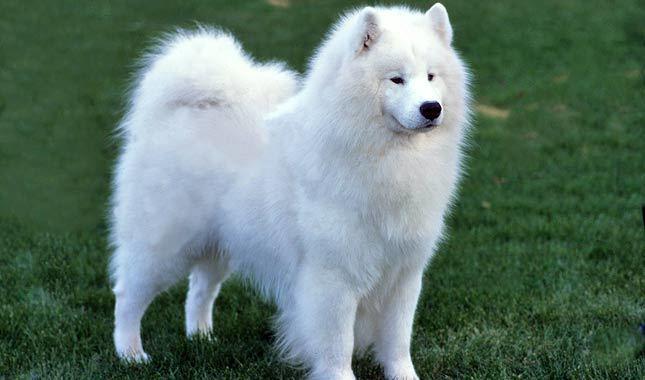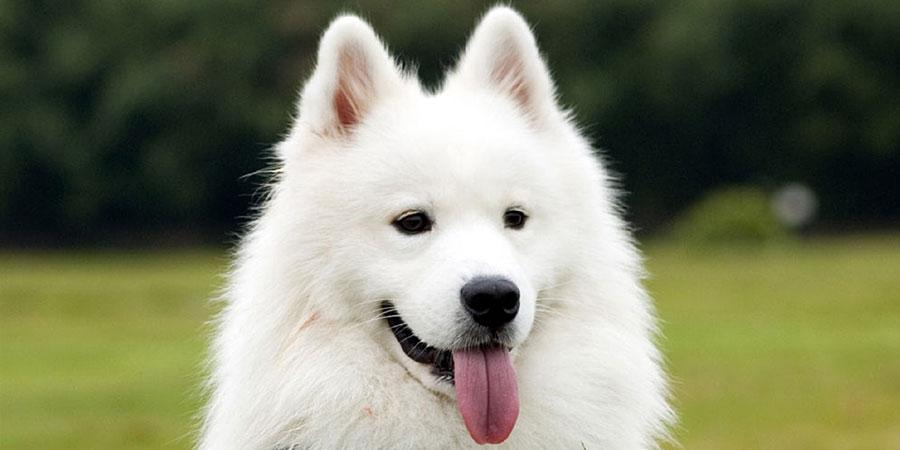The first image is the image on the left, the second image is the image on the right. Evaluate the accuracy of this statement regarding the images: "The dog on the right has its tongue sticking out.". Is it true? Answer yes or no. Yes. 